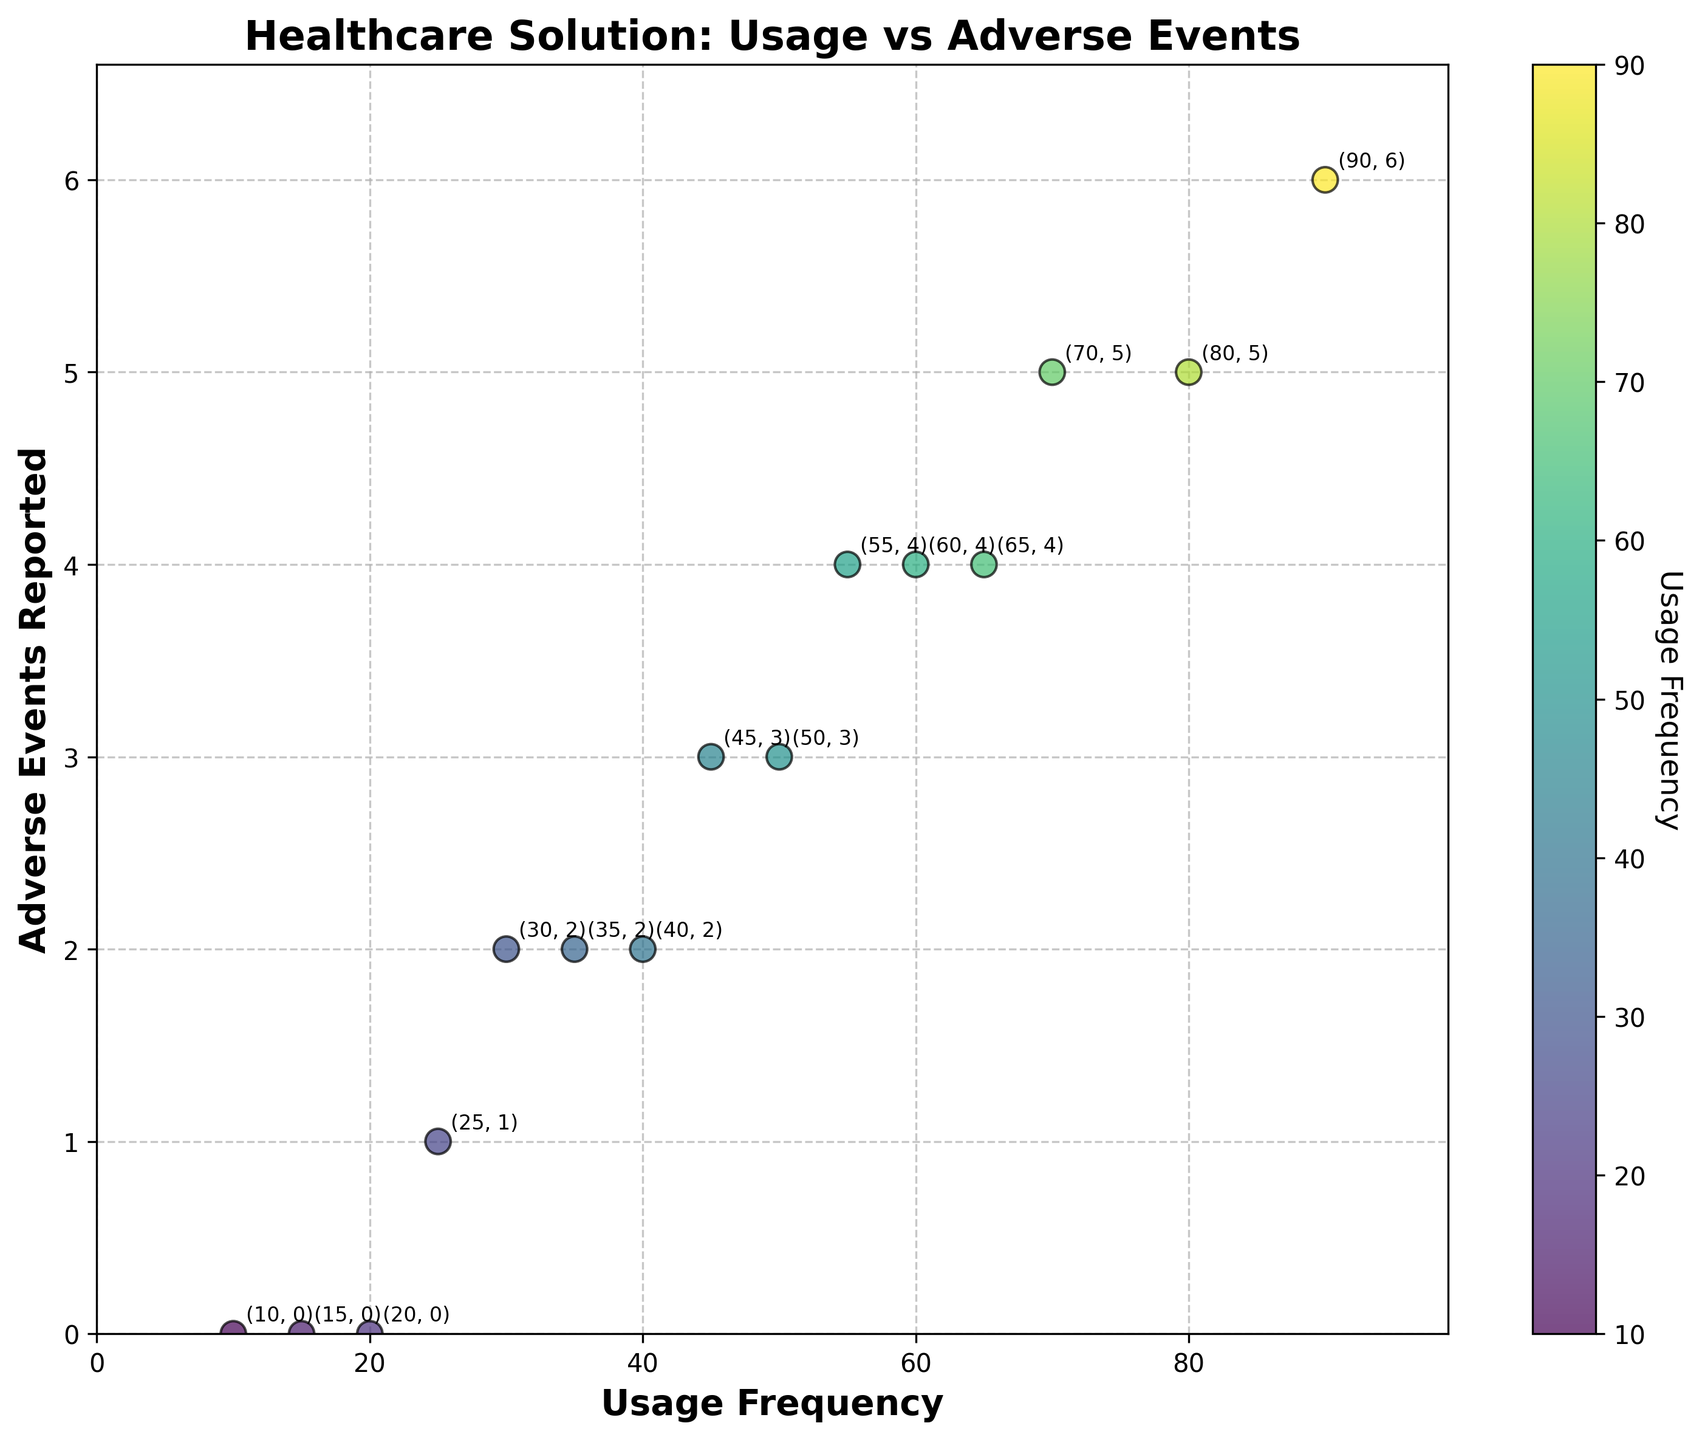What's the title of the figure? The title of the figure is the text displayed at the top.
Answer: Healthcare Solution: Usage vs Adverse Events How many data points are shown on the plot? Each scatter point on the plot represents a data point. Count these points.
Answer: 15 What is the usage frequency for the highest number of adverse events reported? Identify the scatter point with the highest y-value (adverse events) and read the corresponding x-value (usage frequency).
Answer: 90 What is the color range representing the usage frequency in the scatter plot? The color bar on the right side of the plot shows the color range, indicating how colors correspond to usage frequency values.
Answer: Viridis colormap Which usage frequency value corresponds to 3 adverse events? Locate the points where the y-value (adverse events) is 3 and read the corresponding x-values.
Answer: 45, 50 What is the average usage frequency for data points with 0 adverse events? Identify the points where the y-value (adverse events) is 0, sum their x-values (usage frequencies), and divide by the number of such points.
Answer: (10 + 15 + 20) / 3 = 15 Are there any data points with more than 5 adverse events, and if so, what is their usage frequency? Check the plot for points where the y-value (adverse events) is greater than 5 and identify the corresponding x-values (usage frequencies).
Answer: 90 What is the difference in usage frequency between the points with 2 and 4 adverse events? Identify the x-values for points with 2 adverse events and 4 adverse events, then calculate the differences.
Answer: 65 - 35 = 30 How many data points have a usage frequency greater than 50? Count the points where the x-value (usage frequency) is greater than 50.
Answer: 5 Does the plot show a general trend between usage frequency and adverse events, and if so, what is it? Analyze the overall direction of the data points to identify any increasing or decreasing trends in adverse events as usage frequency changes.
Answer: Increasing trend 